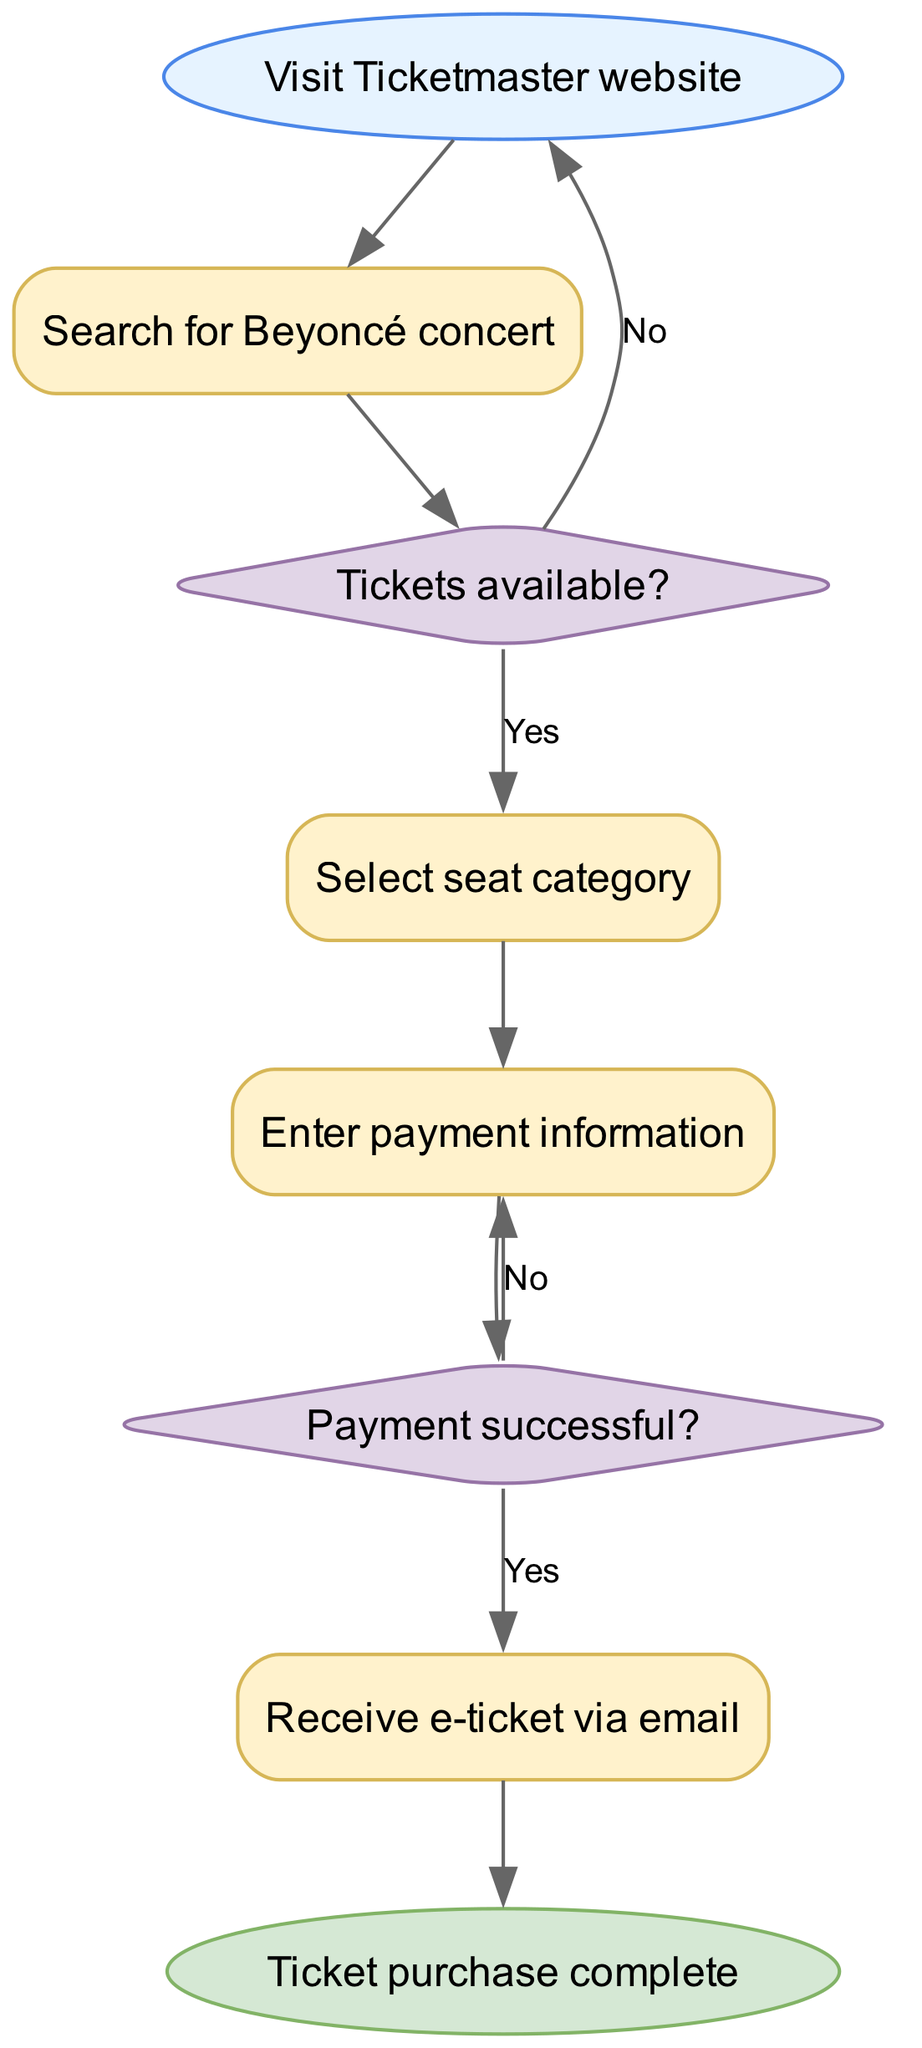What is the first step in the purchasing process? The first step in the purchasing process is "Visit Ticketmaster website." This is indicated as the starting point in the flowchart.
Answer: Visit Ticketmaster website How many decision nodes are in the diagram? There are two decision nodes in the diagram: "Tickets available?" and "Payment successful?" Each decision node represents a point where the process can branch based on yes or no answers.
Answer: 2 What happens if tickets are not available? If tickets are not available, the flowchart indicates a return to the "Visit Ticketmaster website" node. This means the process restarts at that point instead of continuing.
Answer: Visit Ticketmaster website What is the last step in the purchasing process? The final step in the purchasing process is "Ticket purchase complete." This indicates the conclusion of the ticket purchasing workflow in the diagram.
Answer: Ticket purchase complete What should the user do after selecting a seat category? After selecting a seat category, the user is directed to "Enter payment information." This continues the process towards finalizing the ticket purchase.
Answer: Enter payment information What is the outcome if the payment is successful? If the payment is successful, the next action in the flowchart is to "Receive e-ticket via email." This signifies that the purchasing process is progressing successfully.
Answer: Receive e-ticket via email What steps are involved between searching for the concert and receiving the e-ticket? After searching for the concert and confirming tickets are available, the user selects a seat category, enters payment information, and if payment is successful, they then receive the e-ticket via email. This shows a clear flow from ticket searching to e-ticket reception.
Answer: Select seat category, enter payment information, receive e-ticket via email Which node indicates where the process could loop back? "Enter payment information" serves as a node where the process may loop back to itself if the payment is not successful, indicating that the user would need to re-enter their payment data.
Answer: Enter payment information 